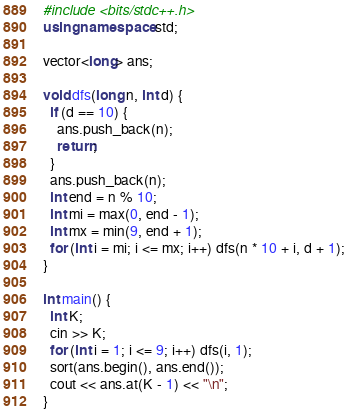<code> <loc_0><loc_0><loc_500><loc_500><_C++_>#include <bits/stdc++.h>
using namespace std;

vector<long> ans;

void dfs(long n, int d) {
  if (d == 10) {
    ans.push_back(n);
    return;
  }
  ans.push_back(n);
  int end = n % 10;
  int mi = max(0, end - 1);
  int mx = min(9, end + 1);
  for (int i = mi; i <= mx; i++) dfs(n * 10 + i, d + 1);
}

int main() {
  int K;
  cin >> K;
  for (int i = 1; i <= 9; i++) dfs(i, 1);
  sort(ans.begin(), ans.end());
  cout << ans.at(K - 1) << "\n";
}</code> 